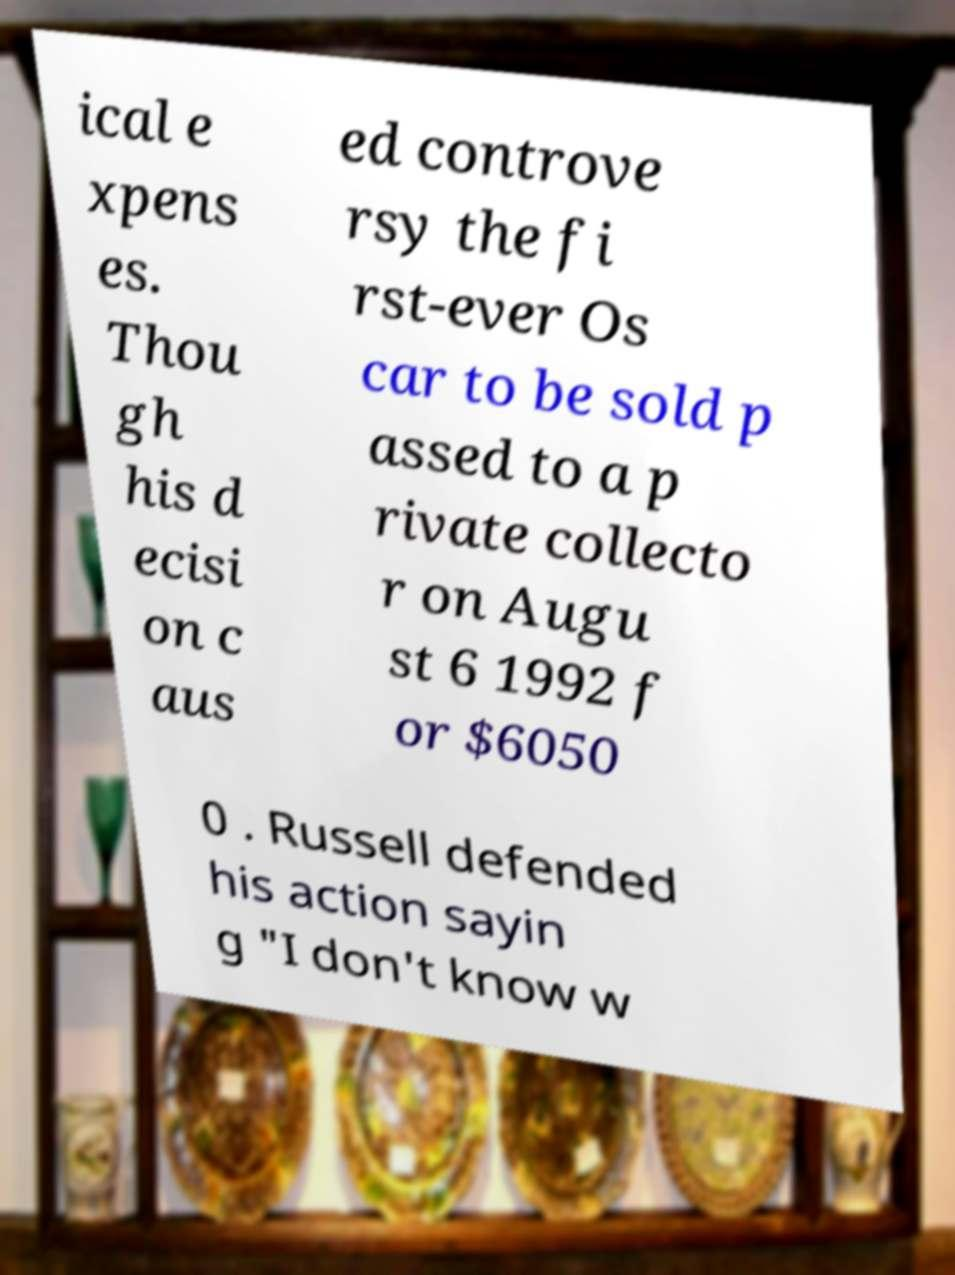Could you assist in decoding the text presented in this image and type it out clearly? ical e xpens es. Thou gh his d ecisi on c aus ed controve rsy the fi rst-ever Os car to be sold p assed to a p rivate collecto r on Augu st 6 1992 f or $6050 0 . Russell defended his action sayin g "I don't know w 